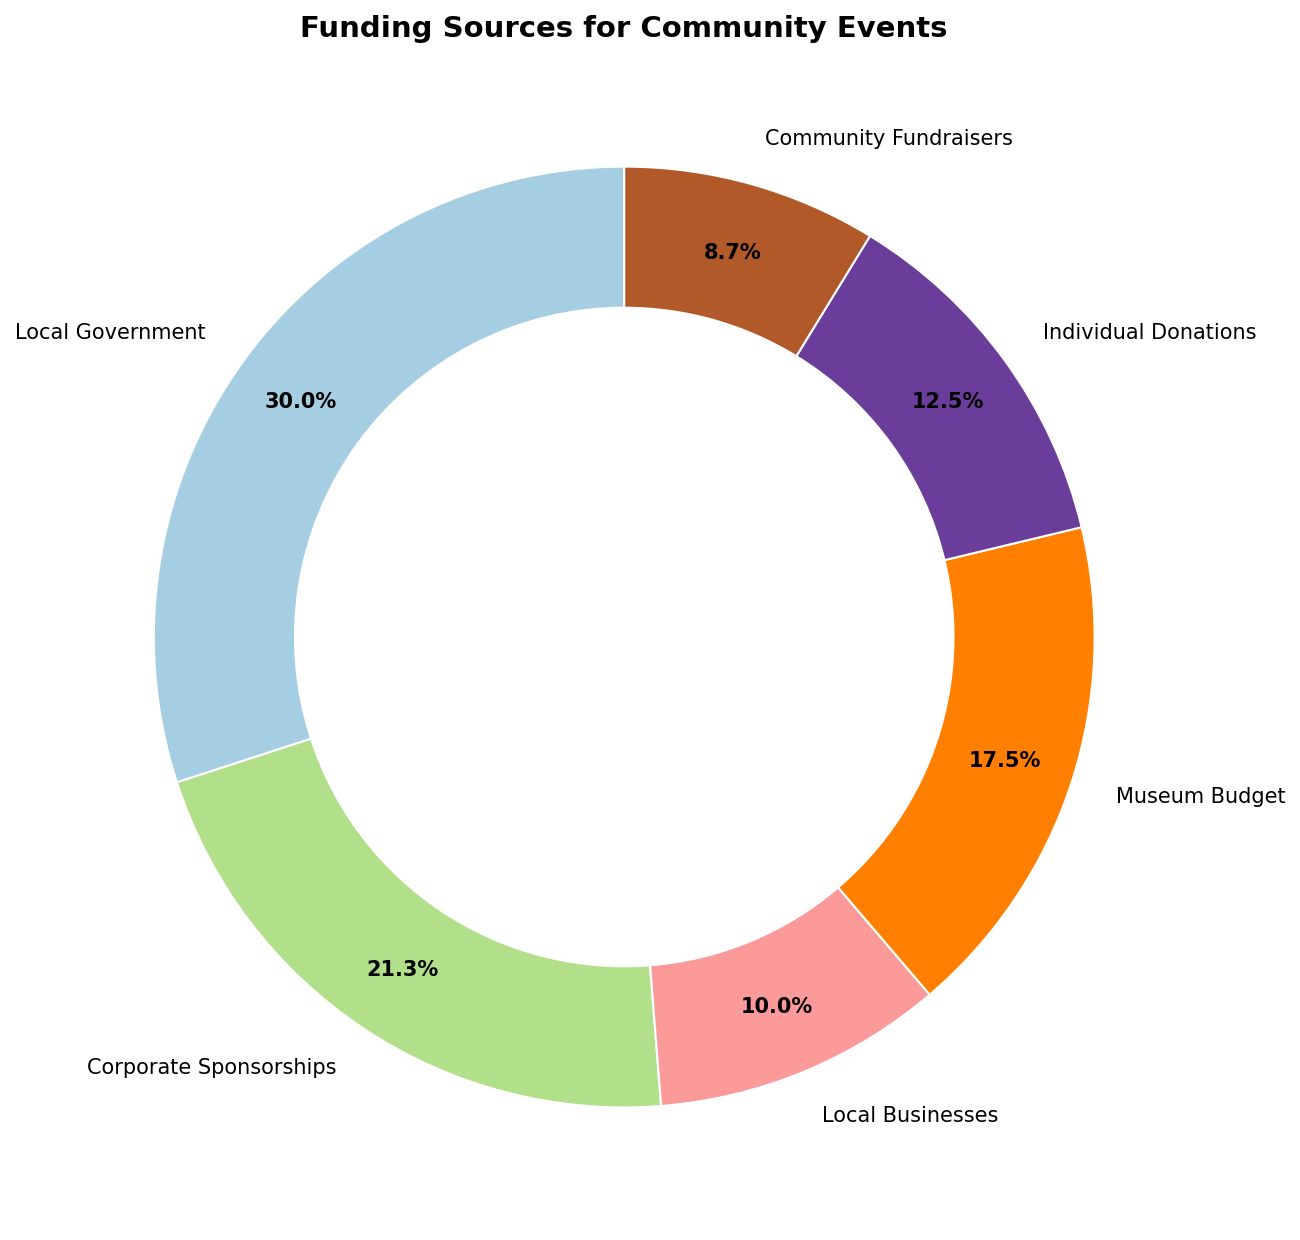Which donor contributed the highest amount? By looking at the ring chart's largest segment, we identify the donor associated with it. The "Local Government" segment is the largest.
Answer: Local Government What percentage of the total funding is from Corporate Sponsorships? The chart labels each segment with its percentage share. The segment labeled "Corporate Sponsorships" shows 21.1%.
Answer: 21.1% Which two donors contributed the least amounts, and what are their combined contributions? By examining the smallest segments, we find "Community Fundraisers" and "Local Businesses." Adding their amounts: 3500 + 4000 = 7500.
Answer: Community Fundraisers & Local Businesses; 7500 Is the contribution from the Museum Budget larger or smaller than Individual Donations, and by how much? Compare the segments' labels for "Museum Budget" (16.2%) and "Individual Donations" (11.6%), then subtract the amounts: (7000 - 5000) = 2000.
Answer: Larger by 2000 Which donor's contribution is exactly 14.7% of the total funding? Check the segment labels for the percentage. "Local Businesses" is labeled 14.7%.
Answer: Local Businesses How much more did the Local Government contribute than Corporate Sponsorships? Compare the labels: Local Government (12000), Corporate Sponsorships (8500). Subtract the amounts: 12000 - 8500 = 3500.
Answer: 3500 If the contributions from Individual Donations and Community Fundraisers were combined, what would be their total percentage of the funding? Add the percentages: Individual Donations (11.6%) + Community Fundraisers (8.1%) = 19.7%.
Answer: 19.7% What color represents the "Museum Budget" on the ring chart? Identify the segment for "Museum Budget" and describe its color. Without the visual, assume a likely distinct color combination like blue.
Answer: Blue (assuming standard palette) 